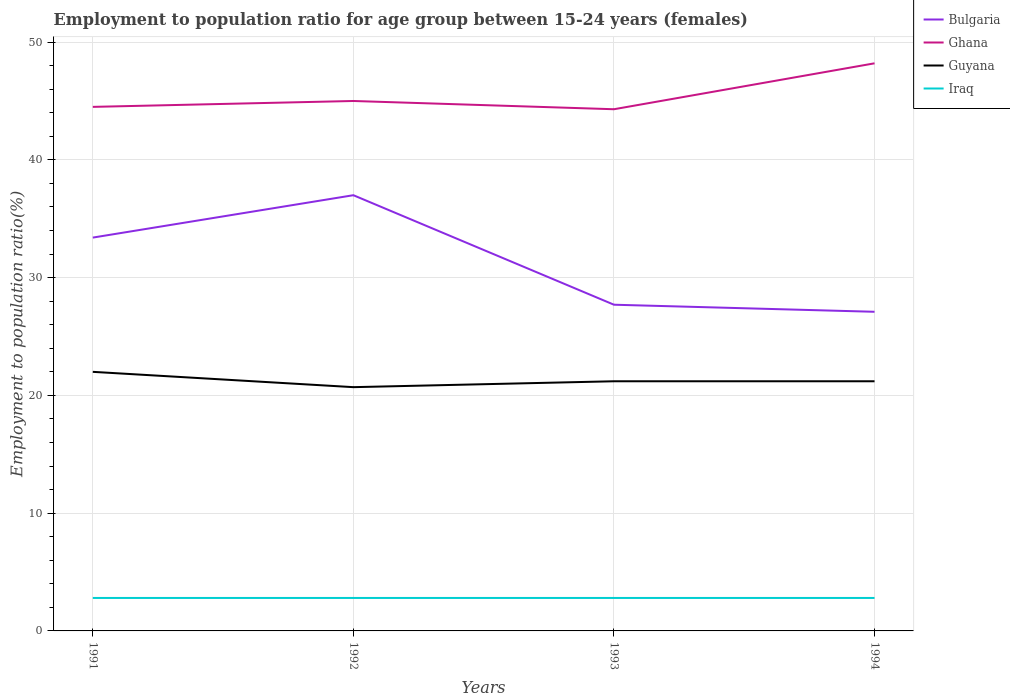How many different coloured lines are there?
Offer a very short reply. 4. Across all years, what is the maximum employment to population ratio in Guyana?
Offer a very short reply. 20.7. In which year was the employment to population ratio in Guyana maximum?
Make the answer very short. 1992. What is the total employment to population ratio in Ghana in the graph?
Offer a terse response. -3.2. What is the difference between the highest and the second highest employment to population ratio in Ghana?
Offer a very short reply. 3.9. What is the difference between the highest and the lowest employment to population ratio in Ghana?
Your answer should be compact. 1. Is the employment to population ratio in Iraq strictly greater than the employment to population ratio in Ghana over the years?
Make the answer very short. Yes. How many lines are there?
Provide a succinct answer. 4. Are the values on the major ticks of Y-axis written in scientific E-notation?
Give a very brief answer. No. Does the graph contain grids?
Your response must be concise. Yes. Where does the legend appear in the graph?
Your response must be concise. Top right. What is the title of the graph?
Give a very brief answer. Employment to population ratio for age group between 15-24 years (females). Does "San Marino" appear as one of the legend labels in the graph?
Provide a short and direct response. No. What is the label or title of the Y-axis?
Your answer should be very brief. Employment to population ratio(%). What is the Employment to population ratio(%) of Bulgaria in 1991?
Keep it short and to the point. 33.4. What is the Employment to population ratio(%) of Ghana in 1991?
Provide a succinct answer. 44.5. What is the Employment to population ratio(%) in Guyana in 1991?
Provide a succinct answer. 22. What is the Employment to population ratio(%) in Iraq in 1991?
Keep it short and to the point. 2.8. What is the Employment to population ratio(%) of Bulgaria in 1992?
Make the answer very short. 37. What is the Employment to population ratio(%) in Guyana in 1992?
Provide a short and direct response. 20.7. What is the Employment to population ratio(%) in Iraq in 1992?
Offer a terse response. 2.8. What is the Employment to population ratio(%) of Bulgaria in 1993?
Provide a short and direct response. 27.7. What is the Employment to population ratio(%) of Ghana in 1993?
Keep it short and to the point. 44.3. What is the Employment to population ratio(%) in Guyana in 1993?
Offer a terse response. 21.2. What is the Employment to population ratio(%) in Iraq in 1993?
Keep it short and to the point. 2.8. What is the Employment to population ratio(%) of Bulgaria in 1994?
Your answer should be compact. 27.1. What is the Employment to population ratio(%) in Ghana in 1994?
Offer a very short reply. 48.2. What is the Employment to population ratio(%) in Guyana in 1994?
Offer a very short reply. 21.2. What is the Employment to population ratio(%) in Iraq in 1994?
Provide a short and direct response. 2.8. Across all years, what is the maximum Employment to population ratio(%) in Ghana?
Make the answer very short. 48.2. Across all years, what is the maximum Employment to population ratio(%) of Iraq?
Give a very brief answer. 2.8. Across all years, what is the minimum Employment to population ratio(%) in Bulgaria?
Provide a succinct answer. 27.1. Across all years, what is the minimum Employment to population ratio(%) in Ghana?
Give a very brief answer. 44.3. Across all years, what is the minimum Employment to population ratio(%) of Guyana?
Your response must be concise. 20.7. Across all years, what is the minimum Employment to population ratio(%) of Iraq?
Your response must be concise. 2.8. What is the total Employment to population ratio(%) of Bulgaria in the graph?
Ensure brevity in your answer.  125.2. What is the total Employment to population ratio(%) in Ghana in the graph?
Keep it short and to the point. 182. What is the total Employment to population ratio(%) in Guyana in the graph?
Your answer should be compact. 85.1. What is the difference between the Employment to population ratio(%) of Bulgaria in 1991 and that in 1992?
Offer a very short reply. -3.6. What is the difference between the Employment to population ratio(%) in Ghana in 1991 and that in 1992?
Give a very brief answer. -0.5. What is the difference between the Employment to population ratio(%) in Guyana in 1991 and that in 1992?
Your answer should be compact. 1.3. What is the difference between the Employment to population ratio(%) of Bulgaria in 1991 and that in 1993?
Keep it short and to the point. 5.7. What is the difference between the Employment to population ratio(%) in Guyana in 1991 and that in 1993?
Ensure brevity in your answer.  0.8. What is the difference between the Employment to population ratio(%) of Bulgaria in 1991 and that in 1994?
Keep it short and to the point. 6.3. What is the difference between the Employment to population ratio(%) in Bulgaria in 1992 and that in 1993?
Your answer should be compact. 9.3. What is the difference between the Employment to population ratio(%) in Ghana in 1992 and that in 1994?
Offer a terse response. -3.2. What is the difference between the Employment to population ratio(%) in Guyana in 1992 and that in 1994?
Provide a succinct answer. -0.5. What is the difference between the Employment to population ratio(%) of Iraq in 1992 and that in 1994?
Provide a succinct answer. 0. What is the difference between the Employment to population ratio(%) of Bulgaria in 1993 and that in 1994?
Your answer should be compact. 0.6. What is the difference between the Employment to population ratio(%) of Iraq in 1993 and that in 1994?
Your answer should be compact. 0. What is the difference between the Employment to population ratio(%) of Bulgaria in 1991 and the Employment to population ratio(%) of Iraq in 1992?
Provide a succinct answer. 30.6. What is the difference between the Employment to population ratio(%) of Ghana in 1991 and the Employment to population ratio(%) of Guyana in 1992?
Provide a short and direct response. 23.8. What is the difference between the Employment to population ratio(%) of Ghana in 1991 and the Employment to population ratio(%) of Iraq in 1992?
Your response must be concise. 41.7. What is the difference between the Employment to population ratio(%) of Bulgaria in 1991 and the Employment to population ratio(%) of Ghana in 1993?
Your answer should be compact. -10.9. What is the difference between the Employment to population ratio(%) of Bulgaria in 1991 and the Employment to population ratio(%) of Iraq in 1993?
Your response must be concise. 30.6. What is the difference between the Employment to population ratio(%) of Ghana in 1991 and the Employment to population ratio(%) of Guyana in 1993?
Provide a short and direct response. 23.3. What is the difference between the Employment to population ratio(%) in Ghana in 1991 and the Employment to population ratio(%) in Iraq in 1993?
Make the answer very short. 41.7. What is the difference between the Employment to population ratio(%) in Bulgaria in 1991 and the Employment to population ratio(%) in Ghana in 1994?
Provide a short and direct response. -14.8. What is the difference between the Employment to population ratio(%) of Bulgaria in 1991 and the Employment to population ratio(%) of Guyana in 1994?
Make the answer very short. 12.2. What is the difference between the Employment to population ratio(%) of Bulgaria in 1991 and the Employment to population ratio(%) of Iraq in 1994?
Your answer should be very brief. 30.6. What is the difference between the Employment to population ratio(%) of Ghana in 1991 and the Employment to population ratio(%) of Guyana in 1994?
Give a very brief answer. 23.3. What is the difference between the Employment to population ratio(%) of Ghana in 1991 and the Employment to population ratio(%) of Iraq in 1994?
Keep it short and to the point. 41.7. What is the difference between the Employment to population ratio(%) in Guyana in 1991 and the Employment to population ratio(%) in Iraq in 1994?
Your response must be concise. 19.2. What is the difference between the Employment to population ratio(%) in Bulgaria in 1992 and the Employment to population ratio(%) in Ghana in 1993?
Your response must be concise. -7.3. What is the difference between the Employment to population ratio(%) of Bulgaria in 1992 and the Employment to population ratio(%) of Iraq in 1993?
Offer a very short reply. 34.2. What is the difference between the Employment to population ratio(%) of Ghana in 1992 and the Employment to population ratio(%) of Guyana in 1993?
Offer a very short reply. 23.8. What is the difference between the Employment to population ratio(%) in Ghana in 1992 and the Employment to population ratio(%) in Iraq in 1993?
Offer a very short reply. 42.2. What is the difference between the Employment to population ratio(%) of Bulgaria in 1992 and the Employment to population ratio(%) of Iraq in 1994?
Your answer should be compact. 34.2. What is the difference between the Employment to population ratio(%) of Ghana in 1992 and the Employment to population ratio(%) of Guyana in 1994?
Provide a short and direct response. 23.8. What is the difference between the Employment to population ratio(%) of Ghana in 1992 and the Employment to population ratio(%) of Iraq in 1994?
Keep it short and to the point. 42.2. What is the difference between the Employment to population ratio(%) of Bulgaria in 1993 and the Employment to population ratio(%) of Ghana in 1994?
Your answer should be very brief. -20.5. What is the difference between the Employment to population ratio(%) of Bulgaria in 1993 and the Employment to population ratio(%) of Iraq in 1994?
Offer a terse response. 24.9. What is the difference between the Employment to population ratio(%) in Ghana in 1993 and the Employment to population ratio(%) in Guyana in 1994?
Give a very brief answer. 23.1. What is the difference between the Employment to population ratio(%) of Ghana in 1993 and the Employment to population ratio(%) of Iraq in 1994?
Give a very brief answer. 41.5. What is the difference between the Employment to population ratio(%) in Guyana in 1993 and the Employment to population ratio(%) in Iraq in 1994?
Make the answer very short. 18.4. What is the average Employment to population ratio(%) in Bulgaria per year?
Provide a short and direct response. 31.3. What is the average Employment to population ratio(%) in Ghana per year?
Your answer should be compact. 45.5. What is the average Employment to population ratio(%) in Guyana per year?
Ensure brevity in your answer.  21.27. In the year 1991, what is the difference between the Employment to population ratio(%) in Bulgaria and Employment to population ratio(%) in Ghana?
Offer a terse response. -11.1. In the year 1991, what is the difference between the Employment to population ratio(%) in Bulgaria and Employment to population ratio(%) in Iraq?
Offer a very short reply. 30.6. In the year 1991, what is the difference between the Employment to population ratio(%) in Ghana and Employment to population ratio(%) in Iraq?
Offer a very short reply. 41.7. In the year 1991, what is the difference between the Employment to population ratio(%) of Guyana and Employment to population ratio(%) of Iraq?
Your answer should be compact. 19.2. In the year 1992, what is the difference between the Employment to population ratio(%) of Bulgaria and Employment to population ratio(%) of Iraq?
Provide a succinct answer. 34.2. In the year 1992, what is the difference between the Employment to population ratio(%) of Ghana and Employment to population ratio(%) of Guyana?
Your answer should be compact. 24.3. In the year 1992, what is the difference between the Employment to population ratio(%) of Ghana and Employment to population ratio(%) of Iraq?
Give a very brief answer. 42.2. In the year 1993, what is the difference between the Employment to population ratio(%) in Bulgaria and Employment to population ratio(%) in Ghana?
Ensure brevity in your answer.  -16.6. In the year 1993, what is the difference between the Employment to population ratio(%) of Bulgaria and Employment to population ratio(%) of Guyana?
Your answer should be compact. 6.5. In the year 1993, what is the difference between the Employment to population ratio(%) in Bulgaria and Employment to population ratio(%) in Iraq?
Keep it short and to the point. 24.9. In the year 1993, what is the difference between the Employment to population ratio(%) of Ghana and Employment to population ratio(%) of Guyana?
Keep it short and to the point. 23.1. In the year 1993, what is the difference between the Employment to population ratio(%) of Ghana and Employment to population ratio(%) of Iraq?
Ensure brevity in your answer.  41.5. In the year 1994, what is the difference between the Employment to population ratio(%) of Bulgaria and Employment to population ratio(%) of Ghana?
Ensure brevity in your answer.  -21.1. In the year 1994, what is the difference between the Employment to population ratio(%) in Bulgaria and Employment to population ratio(%) in Iraq?
Offer a very short reply. 24.3. In the year 1994, what is the difference between the Employment to population ratio(%) of Ghana and Employment to population ratio(%) of Iraq?
Your response must be concise. 45.4. In the year 1994, what is the difference between the Employment to population ratio(%) in Guyana and Employment to population ratio(%) in Iraq?
Offer a very short reply. 18.4. What is the ratio of the Employment to population ratio(%) of Bulgaria in 1991 to that in 1992?
Provide a short and direct response. 0.9. What is the ratio of the Employment to population ratio(%) in Ghana in 1991 to that in 1992?
Offer a terse response. 0.99. What is the ratio of the Employment to population ratio(%) in Guyana in 1991 to that in 1992?
Your answer should be compact. 1.06. What is the ratio of the Employment to population ratio(%) of Bulgaria in 1991 to that in 1993?
Your answer should be compact. 1.21. What is the ratio of the Employment to population ratio(%) in Guyana in 1991 to that in 1993?
Keep it short and to the point. 1.04. What is the ratio of the Employment to population ratio(%) in Iraq in 1991 to that in 1993?
Your answer should be very brief. 1. What is the ratio of the Employment to population ratio(%) in Bulgaria in 1991 to that in 1994?
Provide a short and direct response. 1.23. What is the ratio of the Employment to population ratio(%) in Ghana in 1991 to that in 1994?
Your response must be concise. 0.92. What is the ratio of the Employment to population ratio(%) of Guyana in 1991 to that in 1994?
Your answer should be compact. 1.04. What is the ratio of the Employment to population ratio(%) in Iraq in 1991 to that in 1994?
Provide a short and direct response. 1. What is the ratio of the Employment to population ratio(%) in Bulgaria in 1992 to that in 1993?
Ensure brevity in your answer.  1.34. What is the ratio of the Employment to population ratio(%) in Ghana in 1992 to that in 1993?
Provide a succinct answer. 1.02. What is the ratio of the Employment to population ratio(%) of Guyana in 1992 to that in 1993?
Give a very brief answer. 0.98. What is the ratio of the Employment to population ratio(%) in Iraq in 1992 to that in 1993?
Your response must be concise. 1. What is the ratio of the Employment to population ratio(%) in Bulgaria in 1992 to that in 1994?
Your answer should be compact. 1.37. What is the ratio of the Employment to population ratio(%) of Ghana in 1992 to that in 1994?
Ensure brevity in your answer.  0.93. What is the ratio of the Employment to population ratio(%) in Guyana in 1992 to that in 1994?
Provide a short and direct response. 0.98. What is the ratio of the Employment to population ratio(%) in Iraq in 1992 to that in 1994?
Keep it short and to the point. 1. What is the ratio of the Employment to population ratio(%) of Bulgaria in 1993 to that in 1994?
Make the answer very short. 1.02. What is the ratio of the Employment to population ratio(%) of Ghana in 1993 to that in 1994?
Provide a succinct answer. 0.92. What is the difference between the highest and the second highest Employment to population ratio(%) in Ghana?
Make the answer very short. 3.2. What is the difference between the highest and the second highest Employment to population ratio(%) of Iraq?
Your answer should be very brief. 0. What is the difference between the highest and the lowest Employment to population ratio(%) of Ghana?
Your answer should be very brief. 3.9. What is the difference between the highest and the lowest Employment to population ratio(%) of Guyana?
Offer a very short reply. 1.3. 